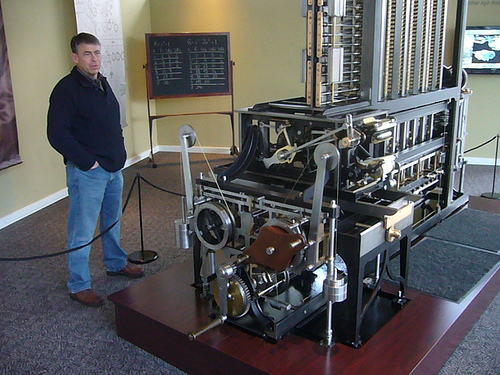<image>
Is there a blackboard in the room? Yes. The blackboard is contained within or inside the room, showing a containment relationship. 